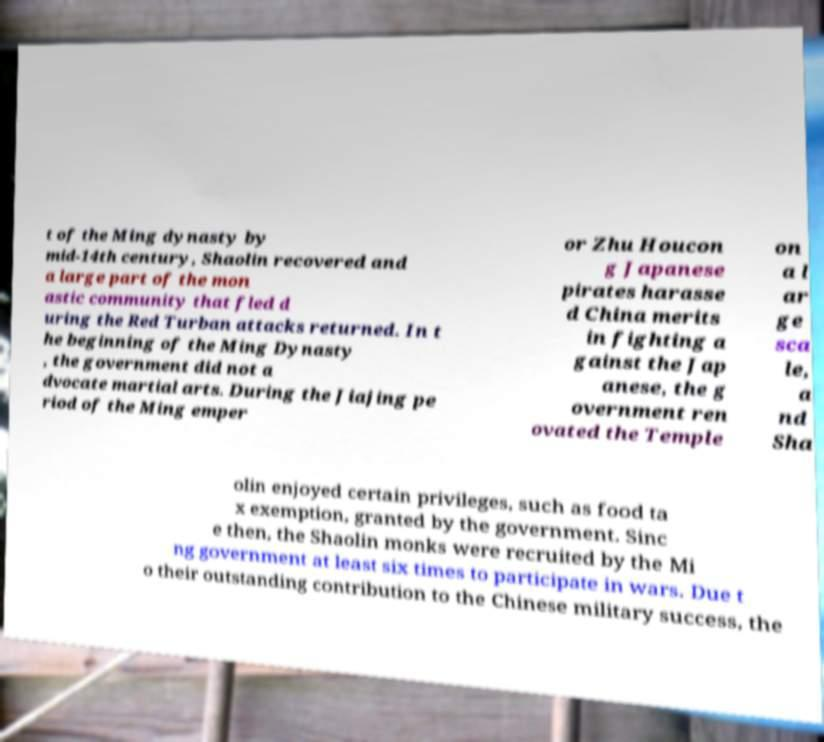For documentation purposes, I need the text within this image transcribed. Could you provide that? t of the Ming dynasty by mid-14th century, Shaolin recovered and a large part of the mon astic community that fled d uring the Red Turban attacks returned. In t he beginning of the Ming Dynasty , the government did not a dvocate martial arts. During the Jiajing pe riod of the Ming emper or Zhu Houcon g Japanese pirates harasse d China merits in fighting a gainst the Jap anese, the g overnment ren ovated the Temple on a l ar ge sca le, a nd Sha olin enjoyed certain privileges, such as food ta x exemption, granted by the government. Sinc e then, the Shaolin monks were recruited by the Mi ng government at least six times to participate in wars. Due t o their outstanding contribution to the Chinese military success, the 